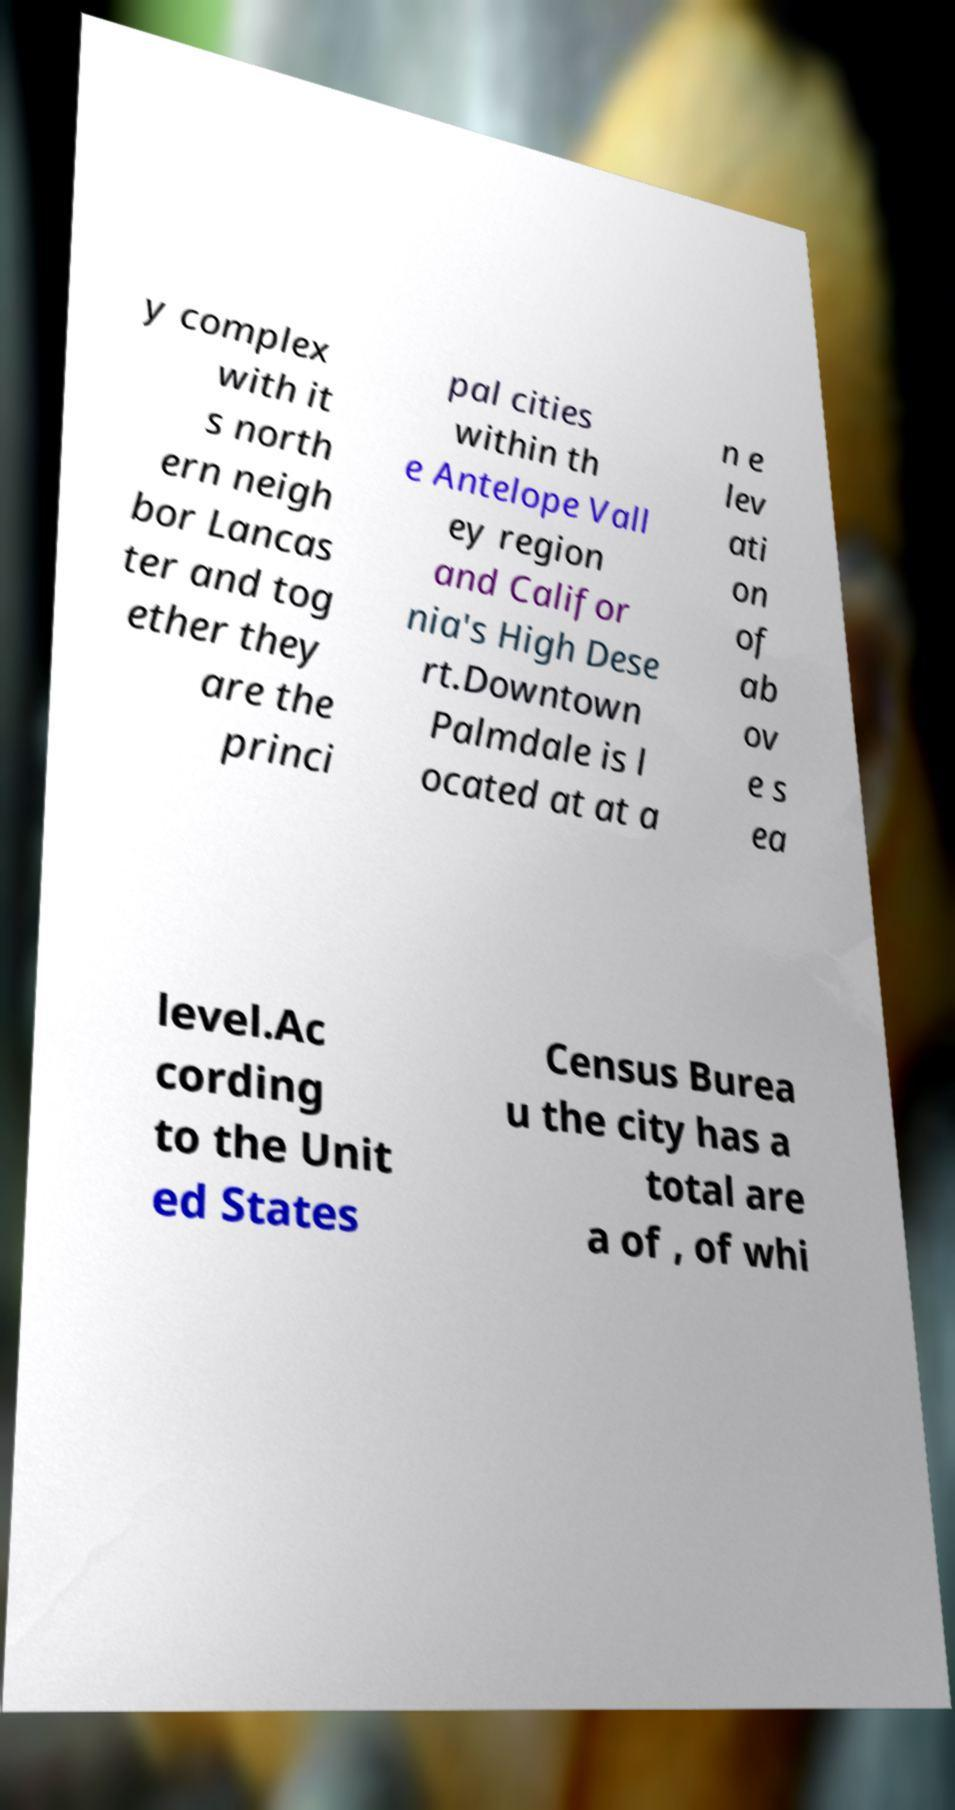Can you accurately transcribe the text from the provided image for me? y complex with it s north ern neigh bor Lancas ter and tog ether they are the princi pal cities within th e Antelope Vall ey region and Califor nia's High Dese rt.Downtown Palmdale is l ocated at at a n e lev ati on of ab ov e s ea level.Ac cording to the Unit ed States Census Burea u the city has a total are a of , of whi 